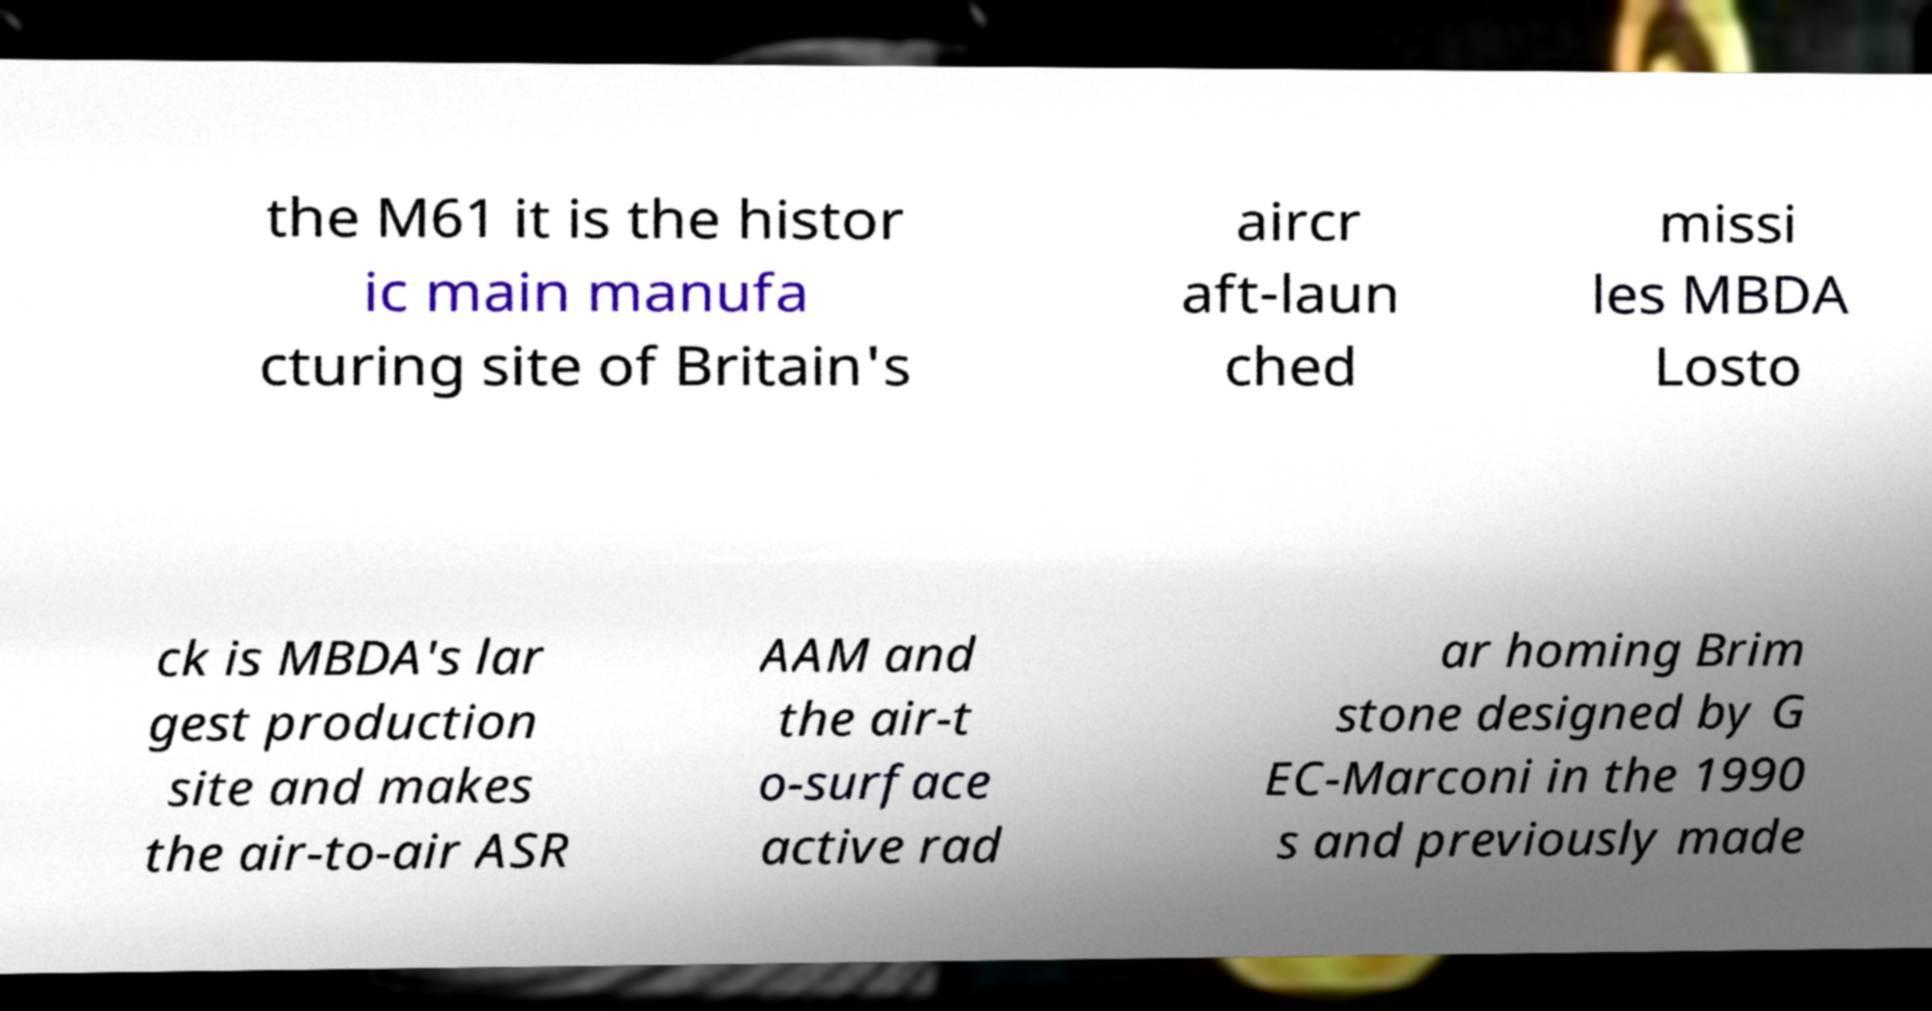Please identify and transcribe the text found in this image. the M61 it is the histor ic main manufa cturing site of Britain's aircr aft-laun ched missi les MBDA Losto ck is MBDA's lar gest production site and makes the air-to-air ASR AAM and the air-t o-surface active rad ar homing Brim stone designed by G EC-Marconi in the 1990 s and previously made 